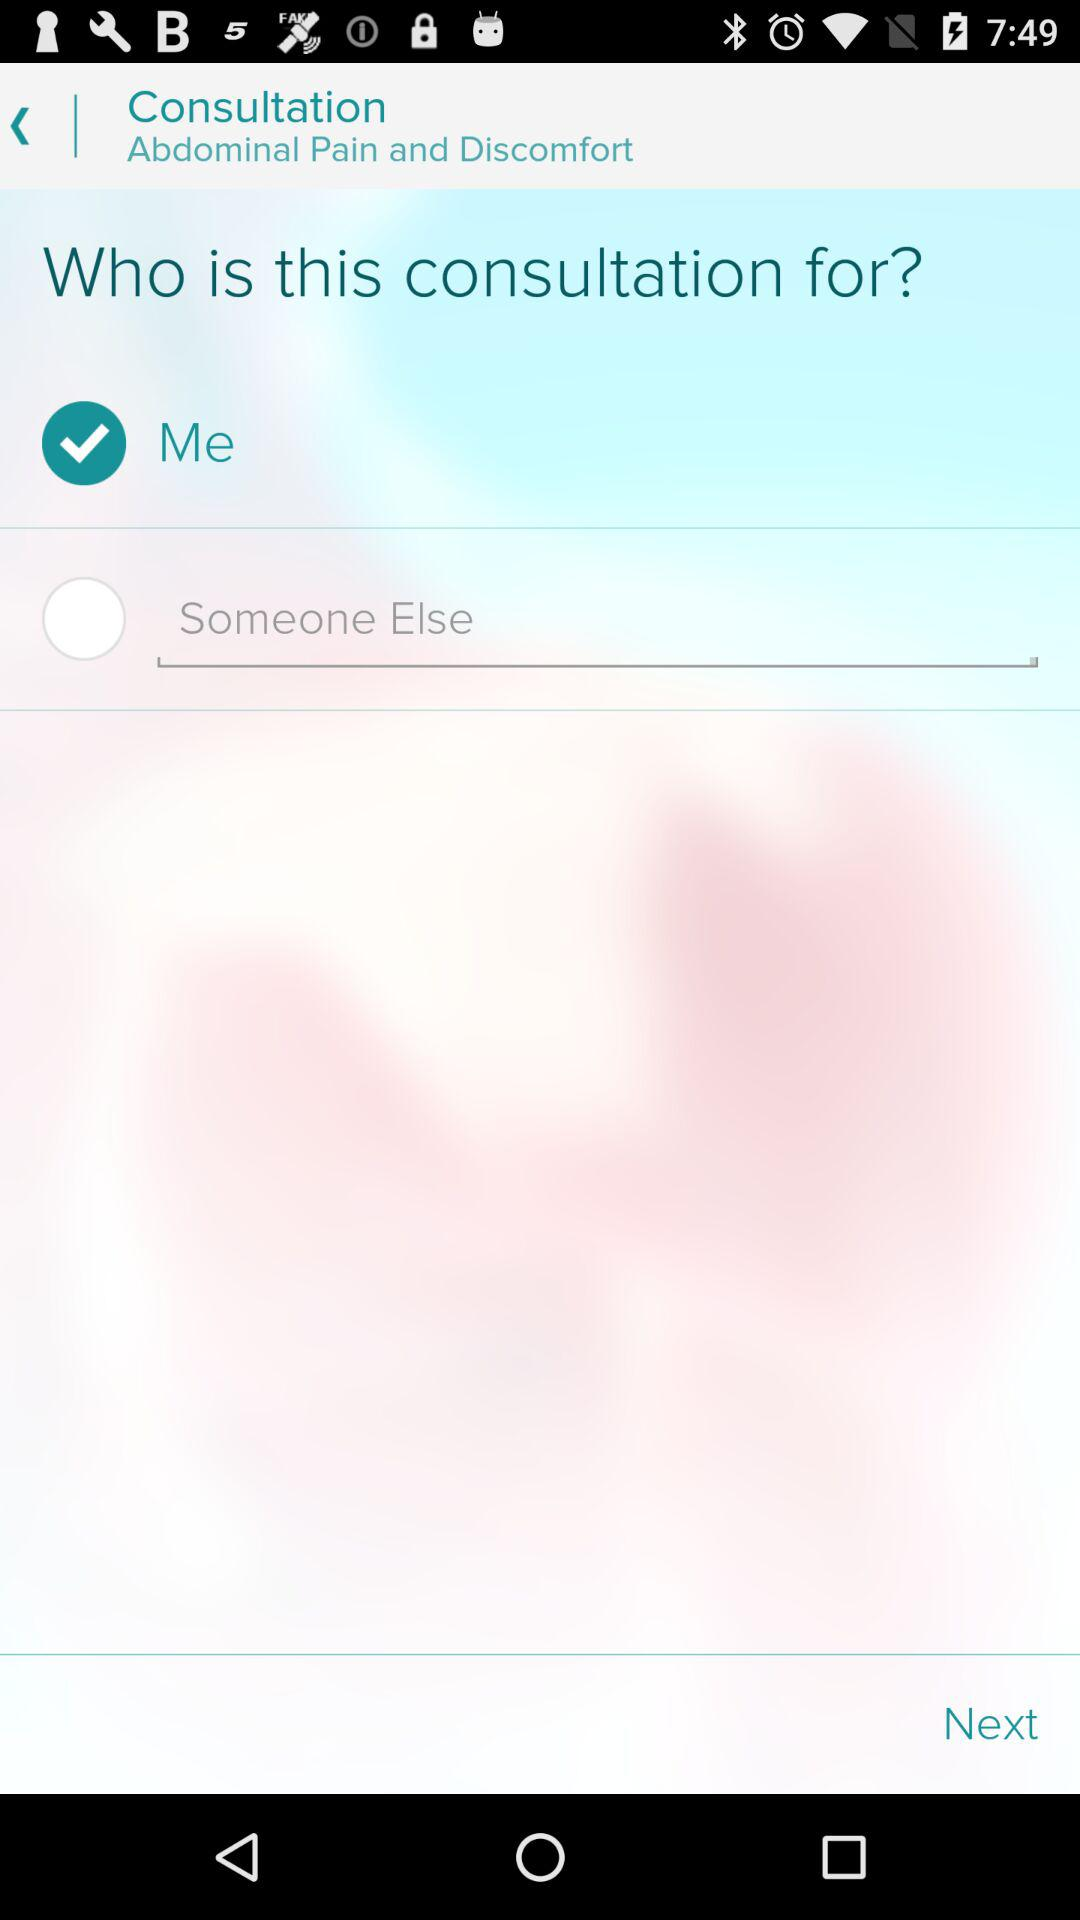How many options are there for the consultation?
Answer the question using a single word or phrase. 2 